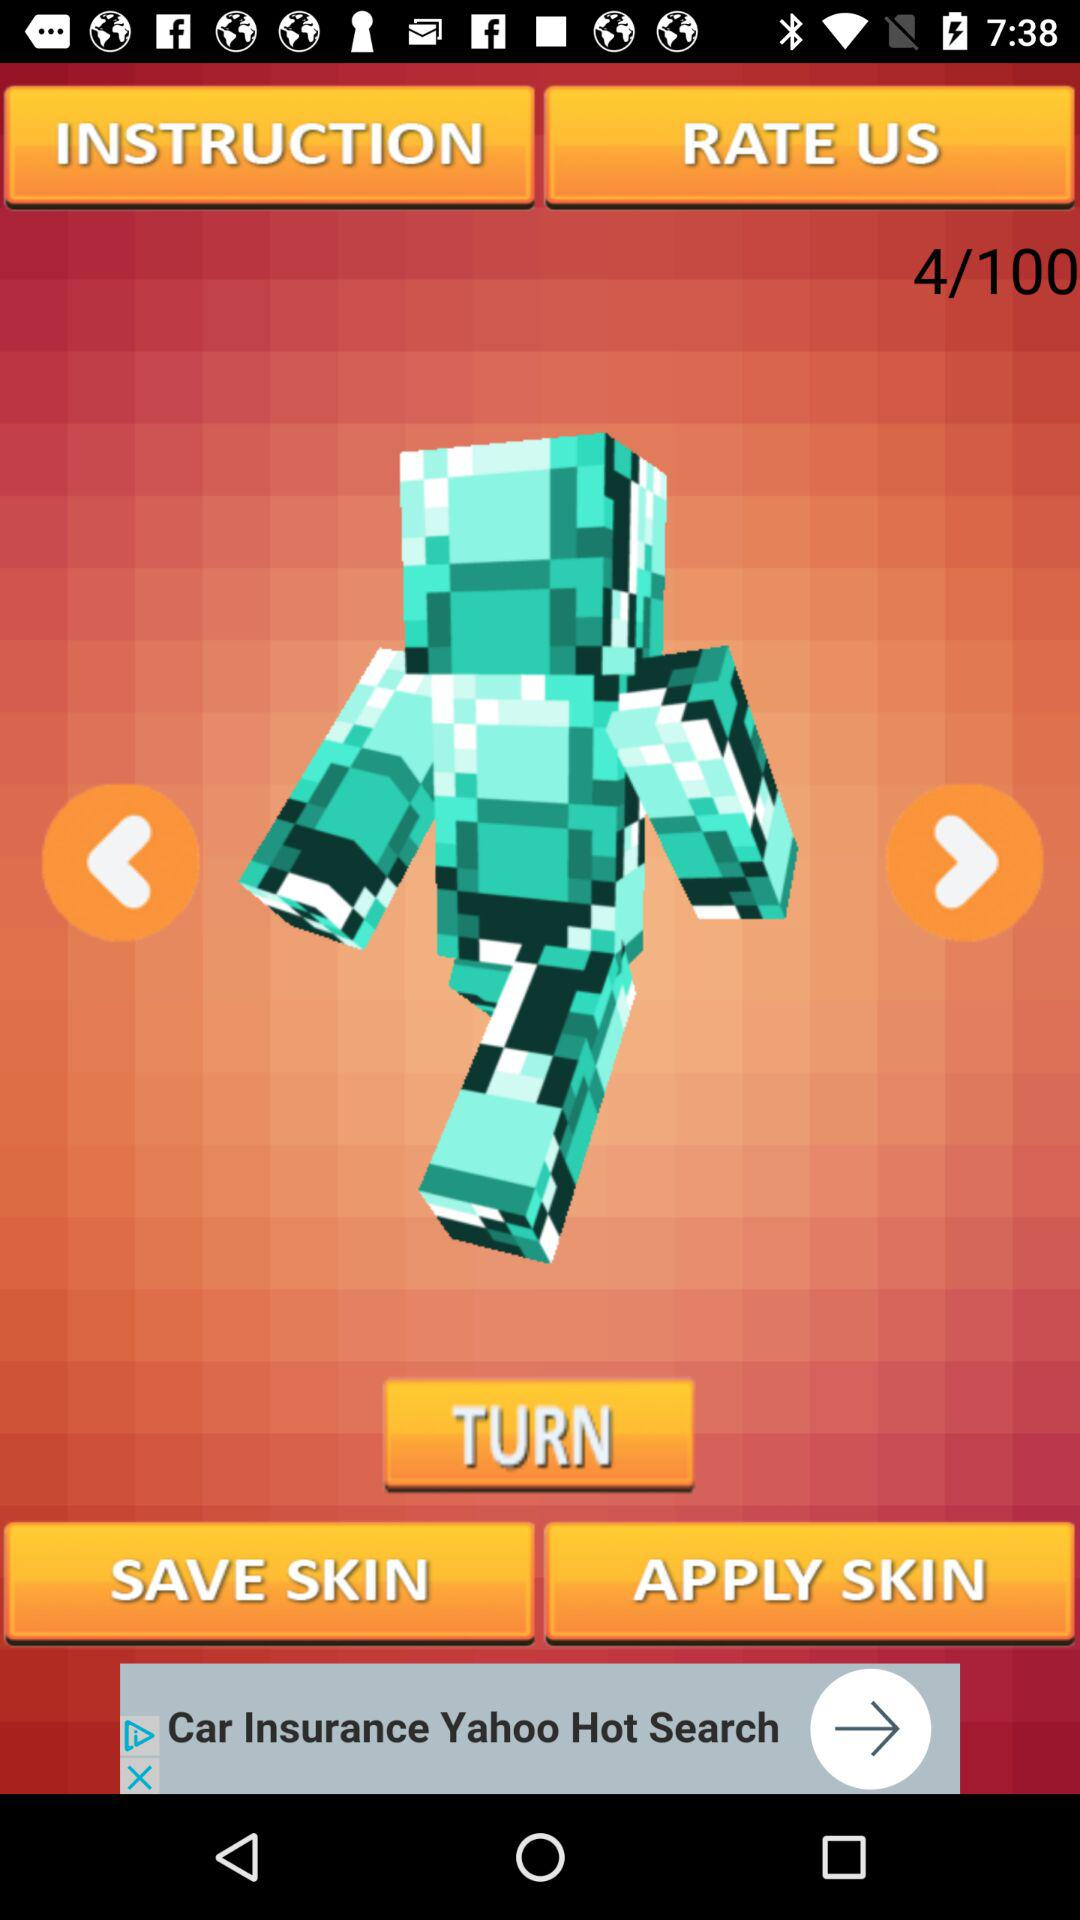At what skin am I at? You are at skin 4. 